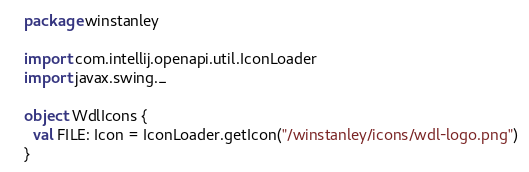Convert code to text. <code><loc_0><loc_0><loc_500><loc_500><_Scala_>package winstanley

import com.intellij.openapi.util.IconLoader
import javax.swing._

object WdlIcons {
  val FILE: Icon = IconLoader.getIcon("/winstanley/icons/wdl-logo.png")
}</code> 